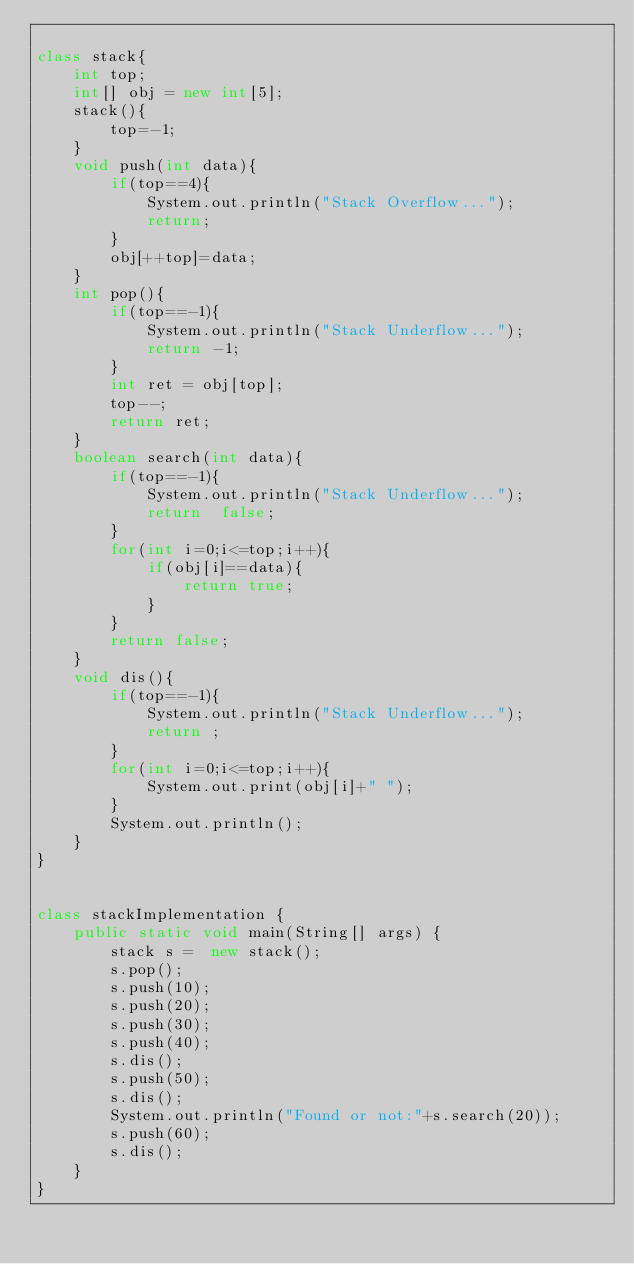<code> <loc_0><loc_0><loc_500><loc_500><_Java_>
class stack{
    int top;
    int[] obj = new int[5];
    stack(){
        top=-1;
    }
    void push(int data){
        if(top==4){
            System.out.println("Stack Overflow...");
            return;
        }
        obj[++top]=data;
    }
    int pop(){
        if(top==-1){
            System.out.println("Stack Underflow...");
            return -1;
        }
        int ret = obj[top];
        top--;
        return ret;
    }
    boolean search(int data){
        if(top==-1){
            System.out.println("Stack Underflow...");
            return  false;
        }
        for(int i=0;i<=top;i++){
            if(obj[i]==data){
                return true;
            }
        }
        return false;
    }
    void dis(){
        if(top==-1){
            System.out.println("Stack Underflow...");
            return ;
        }
        for(int i=0;i<=top;i++){
            System.out.print(obj[i]+" ");
        }
        System.out.println();
    }
}


class stackImplementation {
    public static void main(String[] args) {
        stack s =  new stack();
        s.pop();
        s.push(10);
        s.push(20);
        s.push(30);
        s.push(40);
        s.dis();
        s.push(50);
        s.dis();
        System.out.println("Found or not:"+s.search(20));
        s.push(60);
        s.dis();
    }
}</code> 